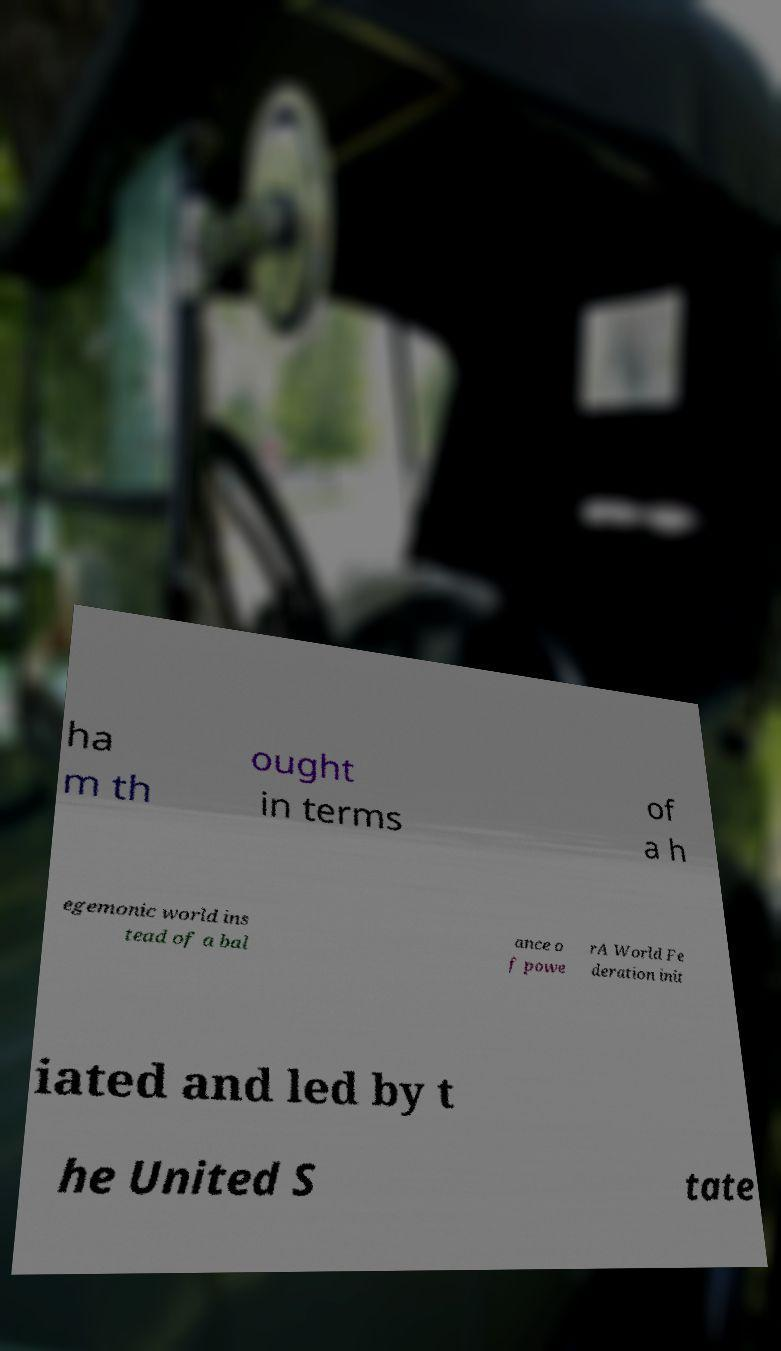Please read and relay the text visible in this image. What does it say? ha m th ought in terms of a h egemonic world ins tead of a bal ance o f powe rA World Fe deration init iated and led by t he United S tate 